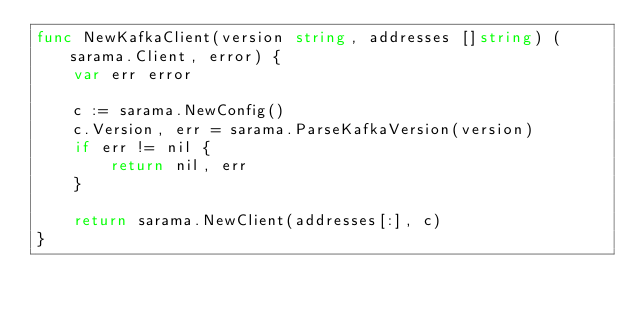<code> <loc_0><loc_0><loc_500><loc_500><_Go_>func NewKafkaClient(version string, addresses []string) (sarama.Client, error) {
	var err error

	c := sarama.NewConfig()
	c.Version, err = sarama.ParseKafkaVersion(version)
	if err != nil {
		return nil, err
	}

	return sarama.NewClient(addresses[:], c)
}
</code> 